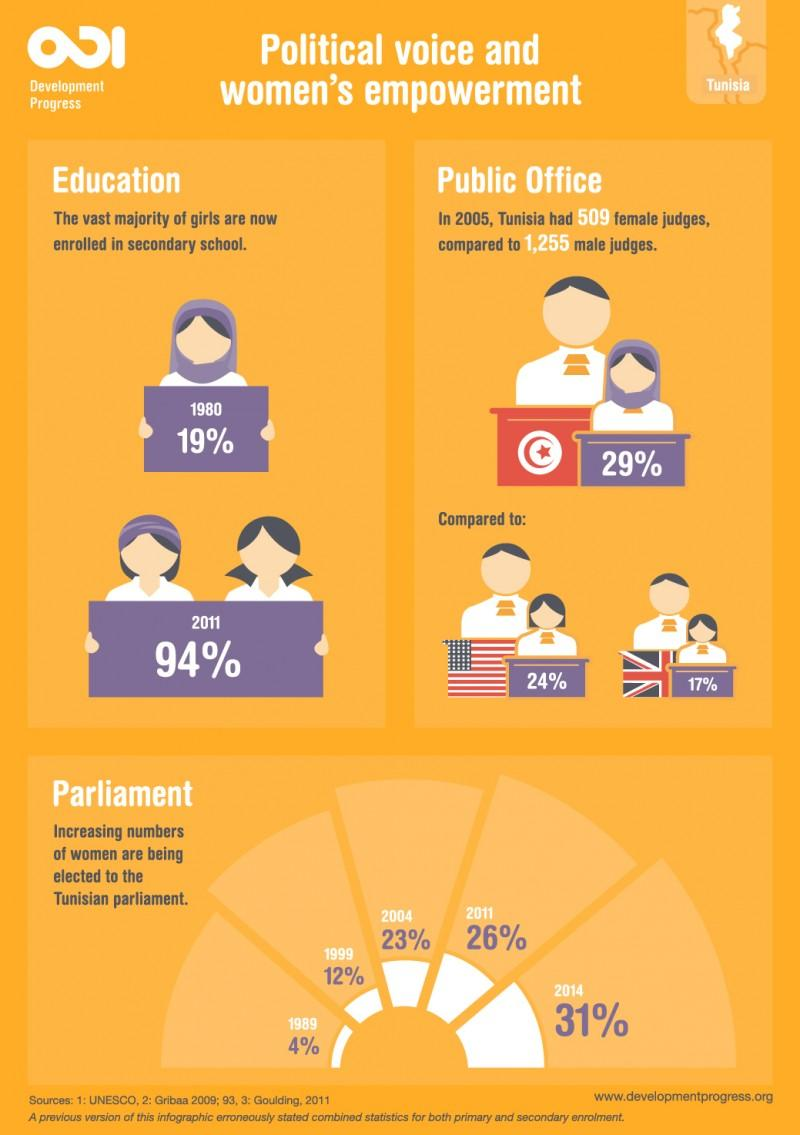Indicate a few pertinent items in this graphic. In Tunisia, only 29% of judges are female. According to recent statistics, only 17% of judges in the United Kingdom are women. According to statistics, only 24% of judges in the United States are female. In 2011, it is estimated that approximately 6% of girls have not been enrolled in school. In 2014, there was a significant increase of 27% in the number of women elected to the Tunisian Parliament compared to 1989. 